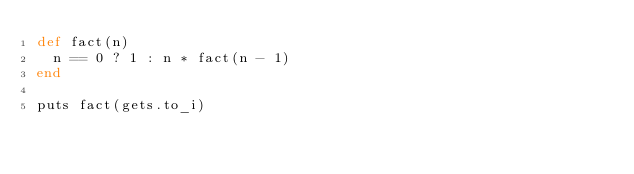Convert code to text. <code><loc_0><loc_0><loc_500><loc_500><_Ruby_>def fact(n)
  n == 0 ? 1 : n * fact(n - 1)
end

puts fact(gets.to_i)</code> 